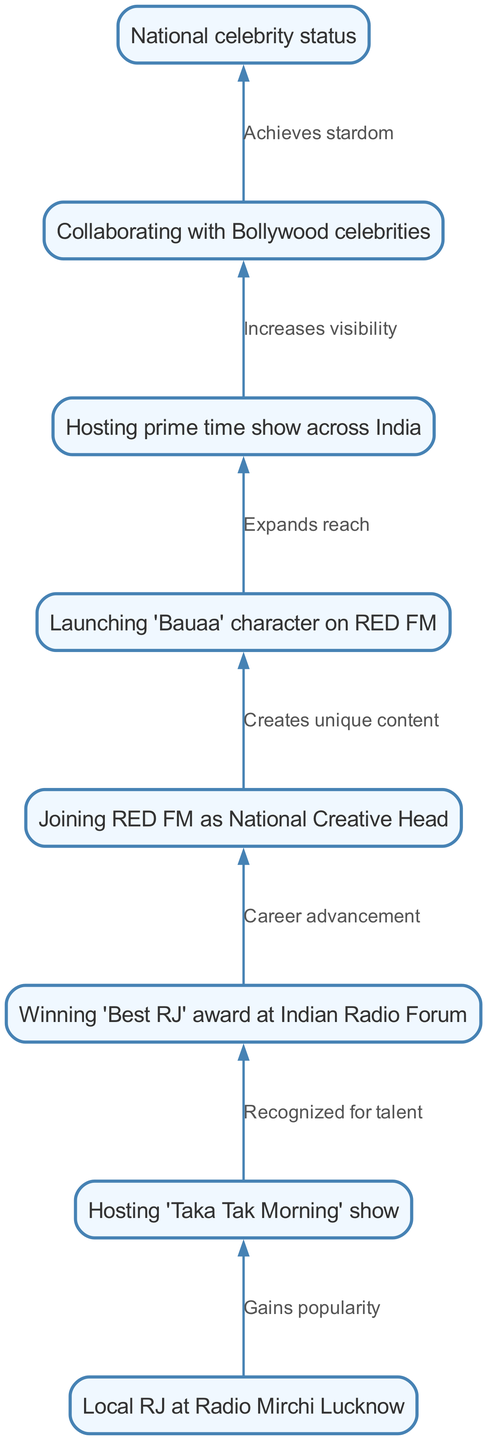What is the first step in RJ Rafiq's career progression? The first node in the diagram shows "Local RJ at Radio Mirchi Lucknow," indicating this is the initial stage of his career before any further advancement.
Answer: Local RJ at Radio Mirchi Lucknow How many nodes are displayed in the diagram? The diagram contains a total of 8 nodes, each representing a significant milestone in RJ Rafiq's career from local RJ to national celebrity.
Answer: 8 What relationship connects the hosting of 'Taka Tak Morning' show to winning the 'Best RJ' award? The edge from node 2 ("Hosting 'Taka Tak Morning' show") to node 3 ("Winning 'Best RJ' award") represents the relationship of being "Recognized for talent," indicating that gaining popularity through the show leads to awards.
Answer: Recognized for talent What character did RJ Rafiq launch while at RED FM? According to the diagram, while RJ Rafiq was at RED FM, he created and launched the 'Bauaa' character, which is highlighted in node 5.
Answer: Bauaa What advancement occurs after winning the 'Best RJ' award? The flow from node 3 ("Winning 'Best RJ' award") to node 4 ("Joining RED FM as National Creative Head") indicates a "Career advancement," showing that winning the award leads him to join a larger organization.
Answer: Career advancement What is the final status RJ Rafiq achieves in his career progression? The last node in the diagram shows "National celebrity status," indicating that through his various milestones, he ultimately achieves this level of recognition.
Answer: National celebrity status Which process expands RJ Rafiq's reach across India? The edge leading from node 5 ("Launching 'Bauaa' character on RED FM") to node 6 ("Hosting prime time show across India") indicates that launching this character contributes to making his show prime-time, thus expanding his reach.
Answer: Expands reach How does collaborating with Bollywood celebrities contribute to RJ Rafiq's career? The diagram shows that the collaboration (from node 7 to node 8) increases his visibility, which is essential for achieving celebrity status, indicating that this is a strategic move in his career.
Answer: Increases visibility 